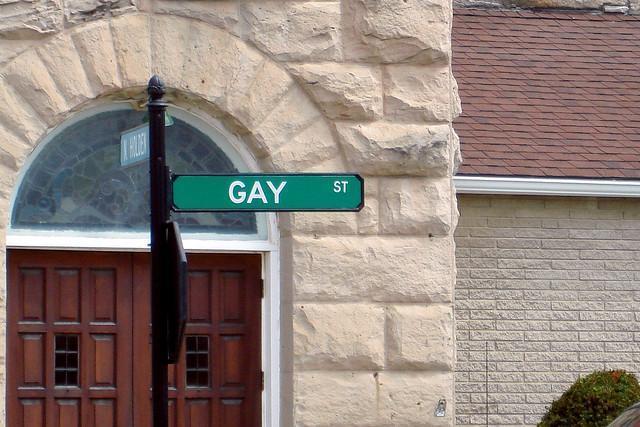How many slices of pizza do you see?
Give a very brief answer. 0. 